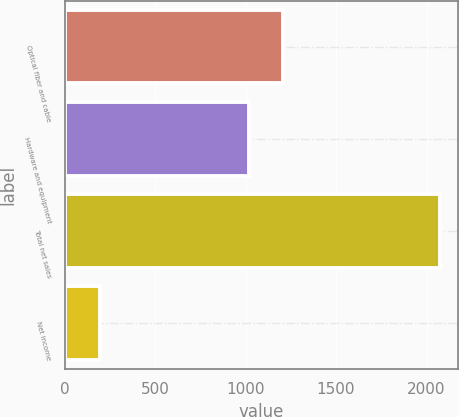Convert chart. <chart><loc_0><loc_0><loc_500><loc_500><bar_chart><fcel>Optical fiber and cable<fcel>Hardware and equipment<fcel>Total net sales<fcel>Net income<nl><fcel>1208.7<fcel>1021<fcel>2072<fcel>195<nl></chart> 